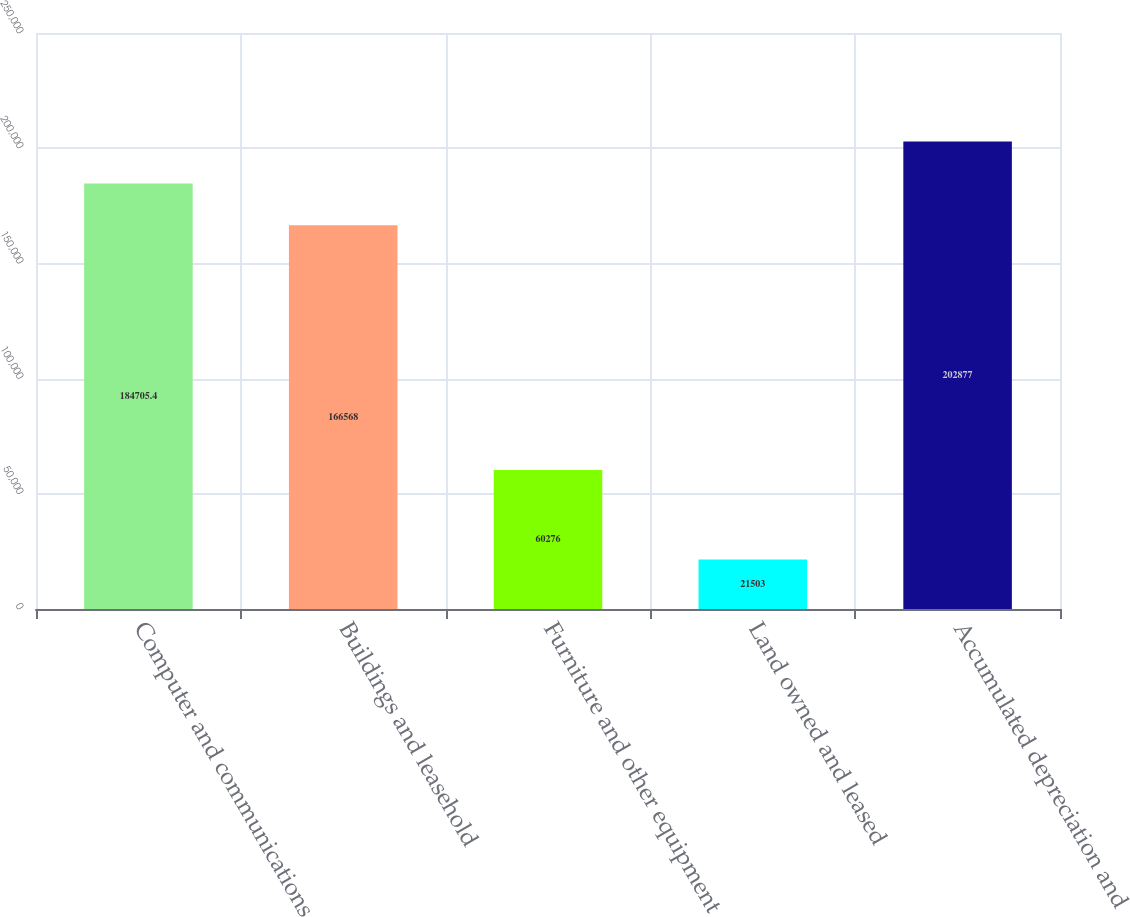Convert chart. <chart><loc_0><loc_0><loc_500><loc_500><bar_chart><fcel>Computer and communications<fcel>Buildings and leasehold<fcel>Furniture and other equipment<fcel>Land owned and leased<fcel>Accumulated depreciation and<nl><fcel>184705<fcel>166568<fcel>60276<fcel>21503<fcel>202877<nl></chart> 